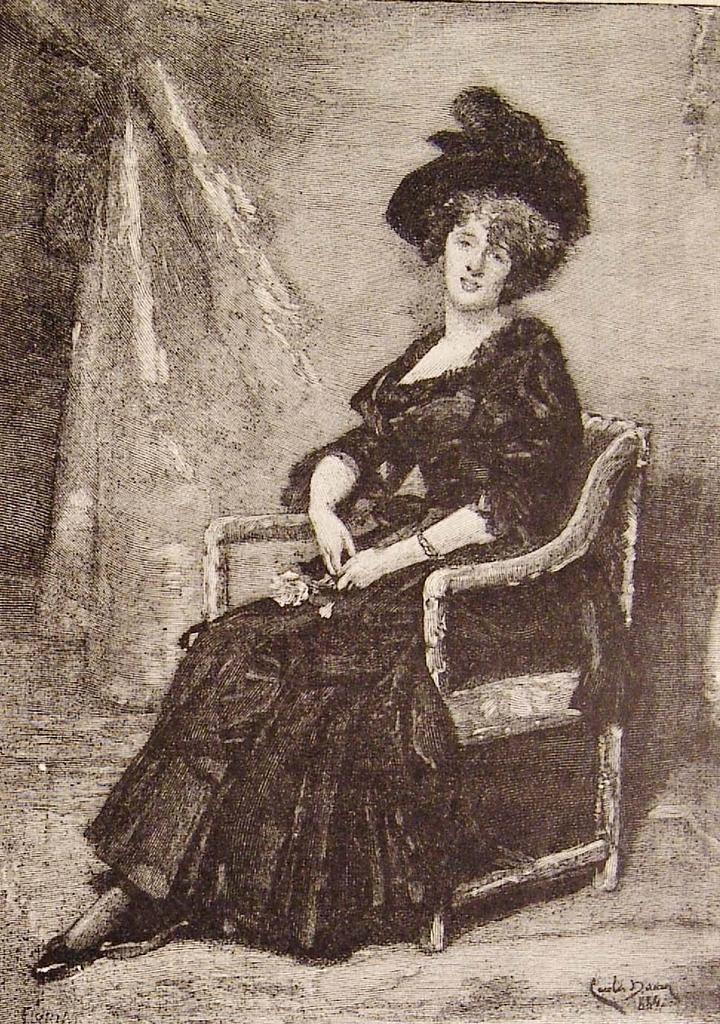What type of artwork is depicted in the image? The image is a painting. Who or what is the main subject of the painting? There is a woman in the painting. What is the woman doing in the painting? The woman is sitting on a chair. Is there any text or marking in the painting? Yes, there is a watermark in the bottom right corner of the painting. How is the background of the painting depicted? The background of the painting is blurred. How does the woman in the painting compete with her parent in the image? There is no parent or competition present in the image; it only features a woman sitting on a chair. 